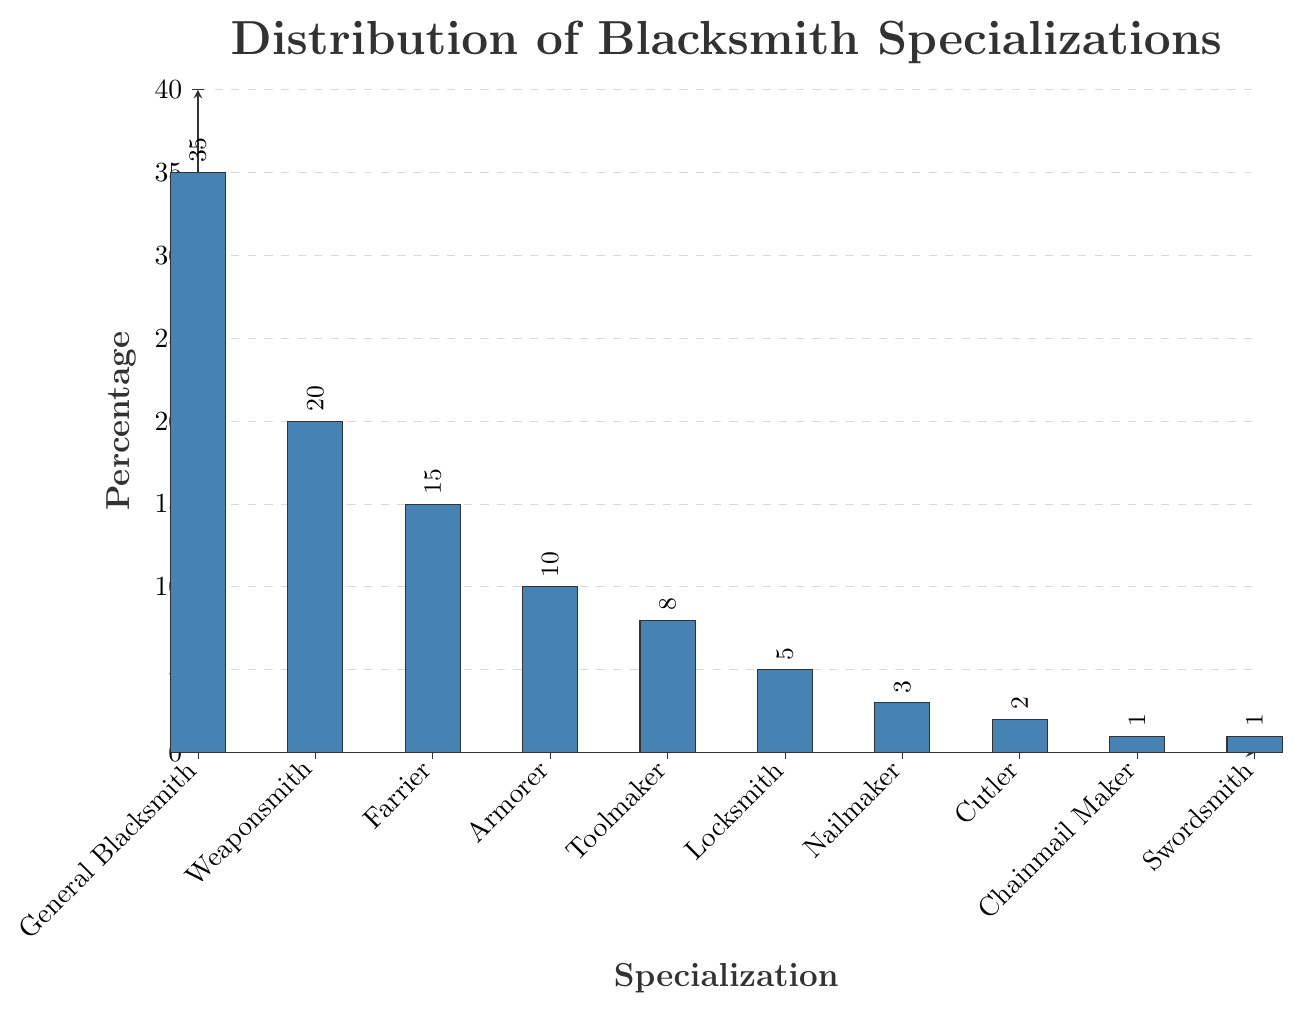Which specialization has the highest percentage? To find the specialization with the highest percentage, look for the tallest bar in the chart. The tallest bar corresponds to the General Blacksmith specialization.
Answer: General Blacksmith Which specializations have a percentage greater than 10%? Check the bars that exceed the 10% mark on the y-axis. The specializations are General Blacksmith, Weaponsmith, and Farrier.
Answer: General Blacksmith, Weaponsmith, Farrier What is the combined percentage of Toolmakers and Locksmiths? Add the percentages for Toolmakers (8%) and Locksmiths (5%). 8% + 5% equals 13%.
Answer: 13% Which specialization has the lowest percentage? Identify the shortest bar in the chart, which corresponds to the Chainmail Maker and Swordsmith specializations. Both have the lowest percentage of 1%.
Answer: Chainmail Maker, Swordsmith How much higher is the percentage of Armorer compared to Nailmaker? Subtract the Nailmaker's percentage (3%) from the Armorer's percentage (10%). 10% - 3% equals 7%.
Answer: 7% How does the percentage of Farrier compare to that of Toolmaker? Compare the percentage of Farrier (15%) and Toolmaker (8%). The percentage of Farrier is greater than that of Toolmaker.
Answer: Farrier What is the total percentage of all blacksmith specializations combined? Sum all percentages: 35 + 20 + 15 + 10 + 8 + 5 + 3 + 2 + 1 + 1 = 100. Since it represents a distribution, the total should be 100%.
Answer: 100% What is the percentage difference between Weaponsmith and Armorer? Subtract the percentage of Armorer (10%) from Weaponsmith (20%). 20% - 10% equals 10%.
Answer: 10% What percentage of specializations fall below 5%? Identify specializations with percentages 5% or less: Locksmith (5%), Nailmaker (3%), Cutler (2%), Chainmail Maker (1%), and Swordsmith (1%). Sum these percentages: 5 + 3 + 2 + 1 + 1 = 12.
Answer: 12% What is the ratio of General Blacksmith to Cutler in terms of their percentage? Divide the percentage of General Blacksmith (35%) by the percentage of Cutler (2%). 35 / 2 equals 17.5.
Answer: 17.5 